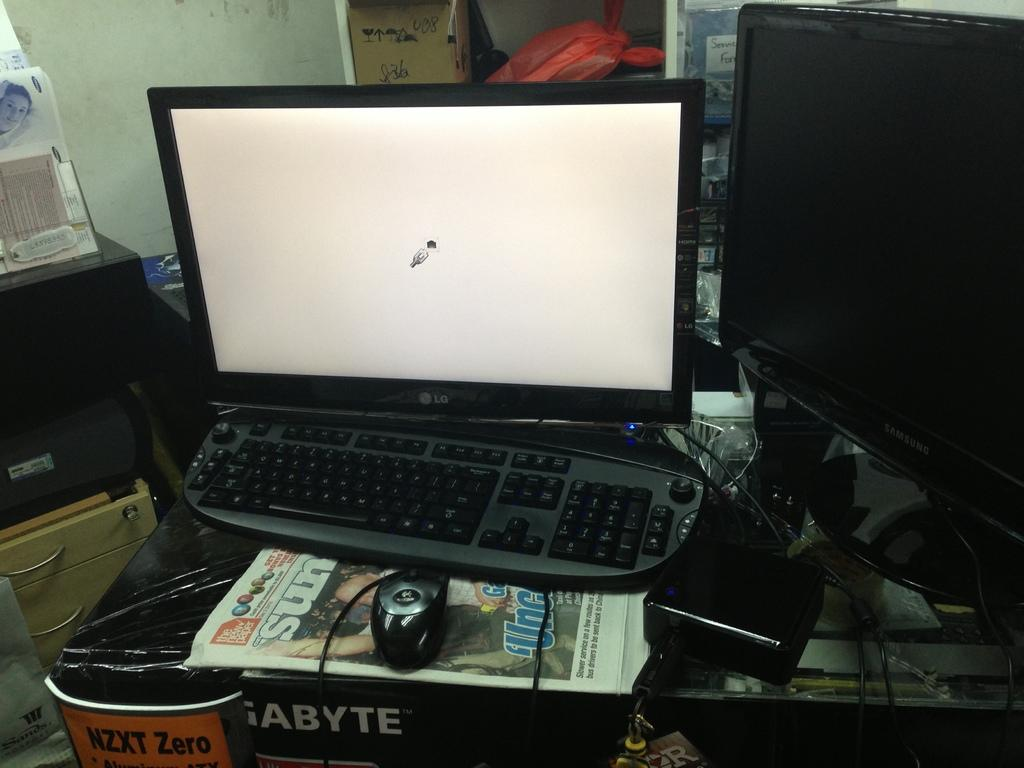Provide a one-sentence caption for the provided image. A computer sits on top of the Sundays's newspaper. 